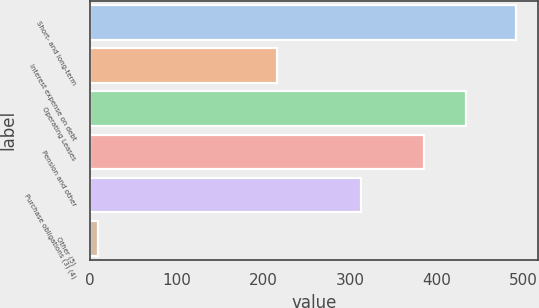Convert chart. <chart><loc_0><loc_0><loc_500><loc_500><bar_chart><fcel>Short- and long-term<fcel>Interest expense on debt<fcel>Operating Leases<fcel>Pension and other<fcel>Purchase obligations (3) (4)<fcel>Other (5)<nl><fcel>492<fcel>216<fcel>434.3<fcel>386<fcel>313<fcel>9<nl></chart> 